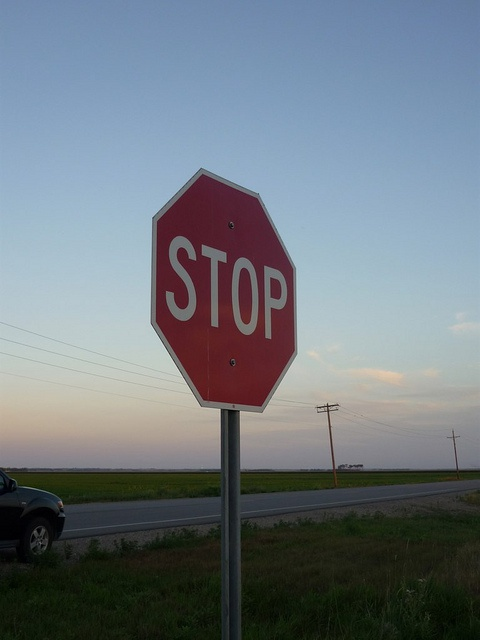Describe the objects in this image and their specific colors. I can see stop sign in gray, maroon, and purple tones and car in gray, black, darkblue, and purple tones in this image. 